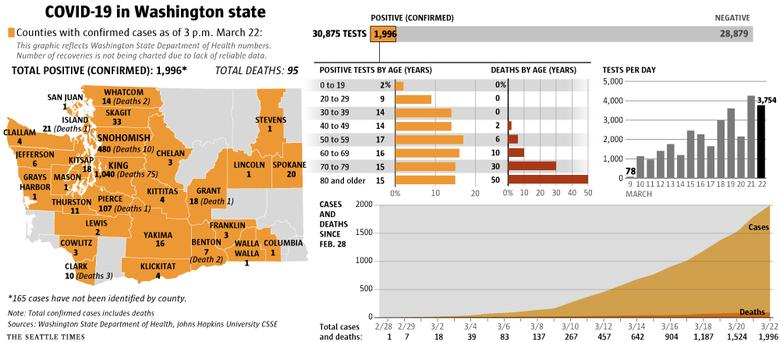Outline some significant characteristics in this image. Of the counties that have reported, only three have reported only one death each. King county has the highest number of deaths among all counties. In total, 1,996 tests were conducted, and out of those tests, a confirmed positive result was obtained. In approximately 8% of counties in Washington, deaths have been reported. Out of the total tests performed, a significant number, approximately 28,879, were negative. 